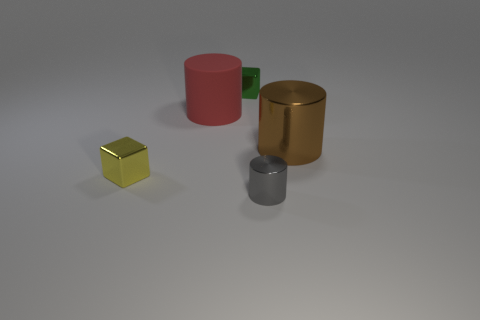Add 4 tiny purple things. How many objects exist? 9 Subtract all blocks. How many objects are left? 3 Add 3 red cylinders. How many red cylinders are left? 4 Add 5 tiny brown shiny balls. How many tiny brown shiny balls exist? 5 Subtract 0 yellow cylinders. How many objects are left? 5 Subtract all tiny yellow cubes. Subtract all big brown things. How many objects are left? 3 